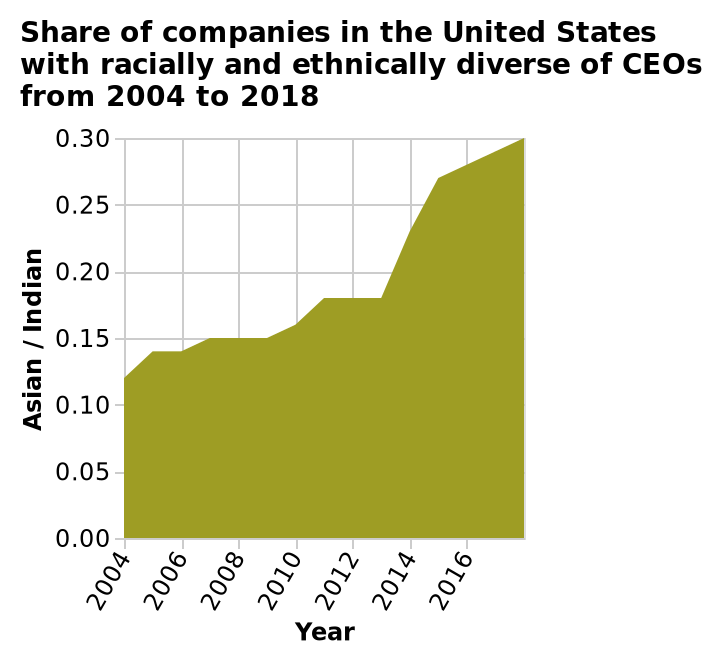<image>
What is plotted on the y-axis of the diagram? The y-axis of the diagram plots the percentage of Asian/Indian CEOs. How has the number of companies with Asian/Indian CEOs changed over the years? The amount of companies with Asian/Indian CEOs has increased year after year. What can be observed about the diversity of CEOs in companies? There has been an increase in Asian/Indian CEOs in companies. 